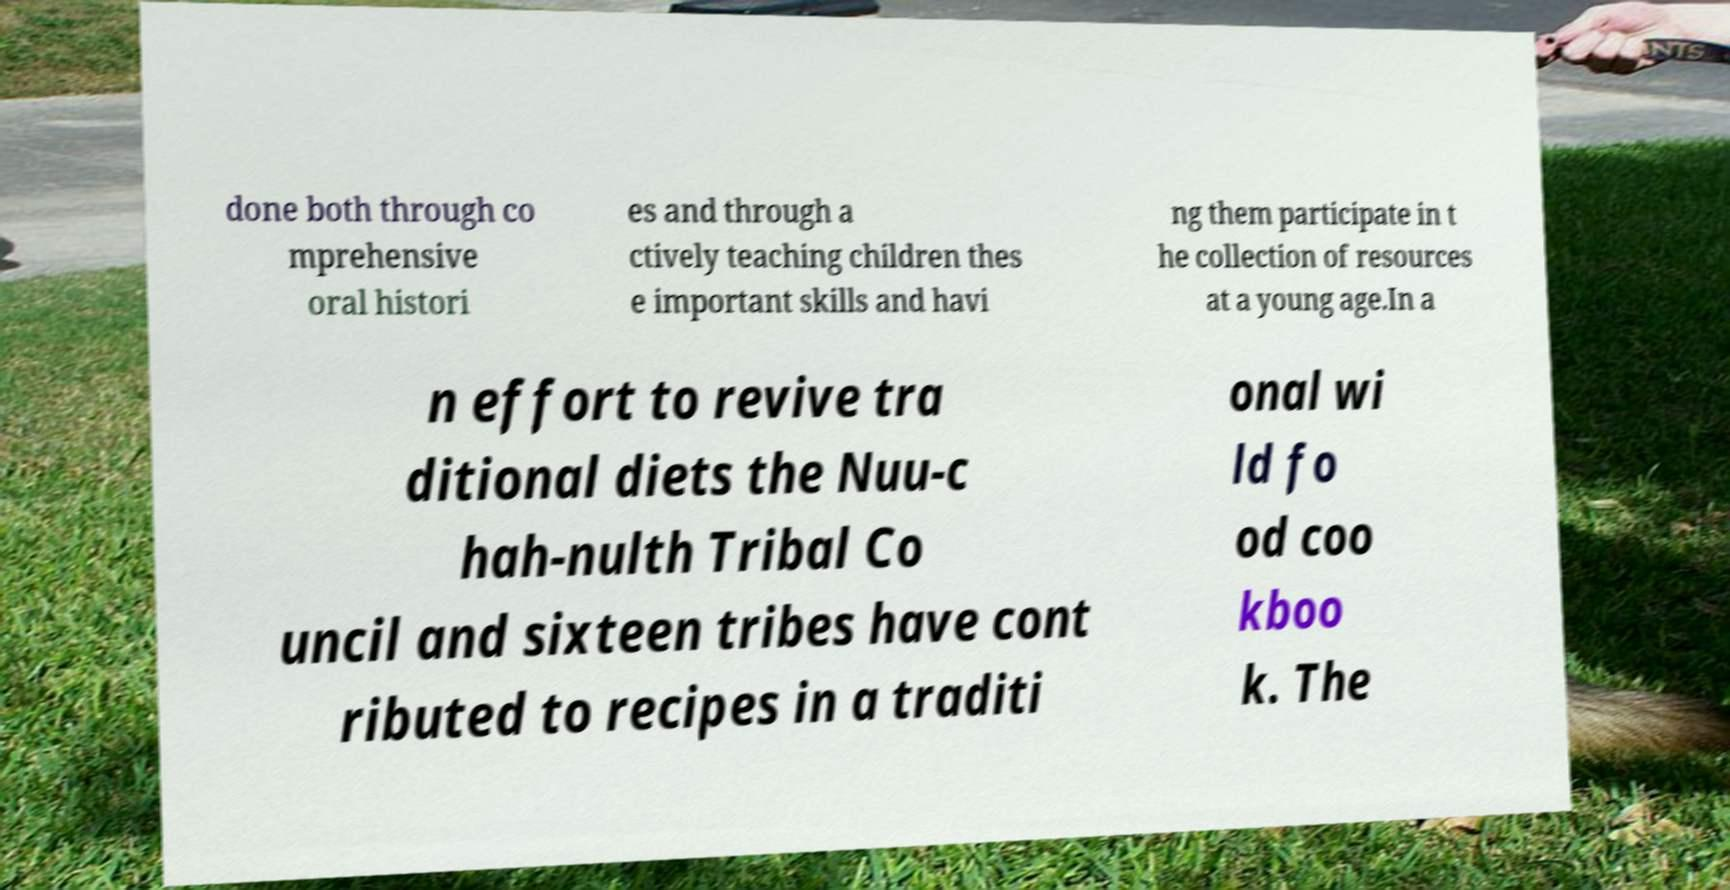For documentation purposes, I need the text within this image transcribed. Could you provide that? done both through co mprehensive oral histori es and through a ctively teaching children thes e important skills and havi ng them participate in t he collection of resources at a young age.In a n effort to revive tra ditional diets the Nuu-c hah-nulth Tribal Co uncil and sixteen tribes have cont ributed to recipes in a traditi onal wi ld fo od coo kboo k. The 